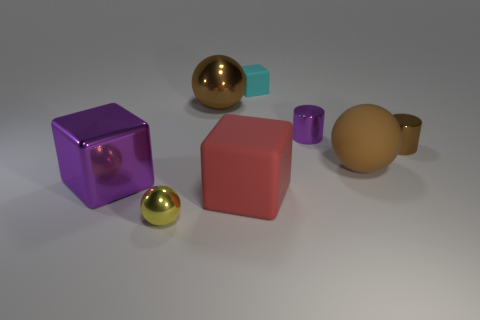Add 2 purple shiny objects. How many objects exist? 10 Subtract all spheres. How many objects are left? 5 Add 3 small brown metallic things. How many small brown metallic things are left? 4 Add 8 gray cylinders. How many gray cylinders exist? 8 Subtract 1 purple cubes. How many objects are left? 7 Subtract all tiny shiny cylinders. Subtract all cylinders. How many objects are left? 4 